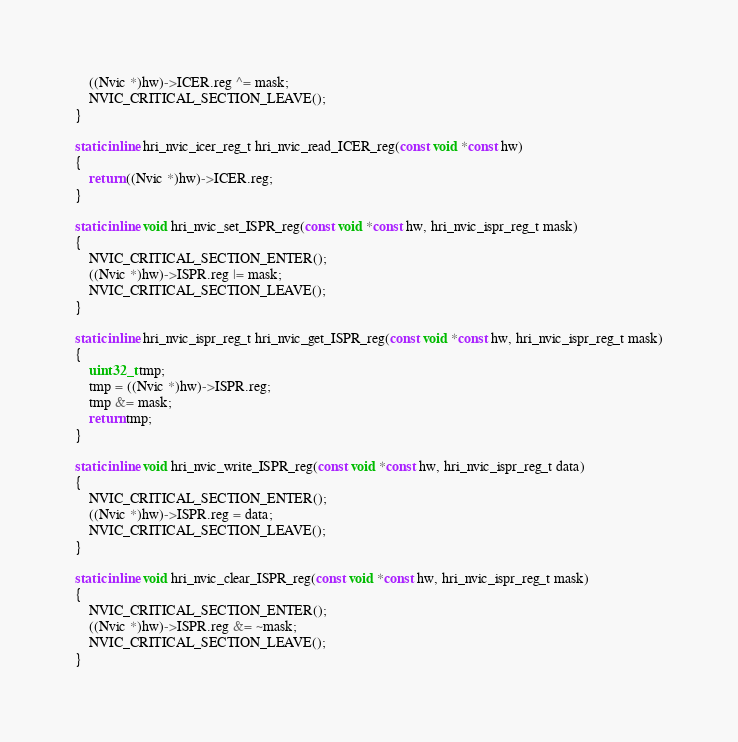Convert code to text. <code><loc_0><loc_0><loc_500><loc_500><_C_>	((Nvic *)hw)->ICER.reg ^= mask;
	NVIC_CRITICAL_SECTION_LEAVE();
}

static inline hri_nvic_icer_reg_t hri_nvic_read_ICER_reg(const void *const hw)
{
	return ((Nvic *)hw)->ICER.reg;
}

static inline void hri_nvic_set_ISPR_reg(const void *const hw, hri_nvic_ispr_reg_t mask)
{
	NVIC_CRITICAL_SECTION_ENTER();
	((Nvic *)hw)->ISPR.reg |= mask;
	NVIC_CRITICAL_SECTION_LEAVE();
}

static inline hri_nvic_ispr_reg_t hri_nvic_get_ISPR_reg(const void *const hw, hri_nvic_ispr_reg_t mask)
{
	uint32_t tmp;
	tmp = ((Nvic *)hw)->ISPR.reg;
	tmp &= mask;
	return tmp;
}

static inline void hri_nvic_write_ISPR_reg(const void *const hw, hri_nvic_ispr_reg_t data)
{
	NVIC_CRITICAL_SECTION_ENTER();
	((Nvic *)hw)->ISPR.reg = data;
	NVIC_CRITICAL_SECTION_LEAVE();
}

static inline void hri_nvic_clear_ISPR_reg(const void *const hw, hri_nvic_ispr_reg_t mask)
{
	NVIC_CRITICAL_SECTION_ENTER();
	((Nvic *)hw)->ISPR.reg &= ~mask;
	NVIC_CRITICAL_SECTION_LEAVE();
}
</code> 